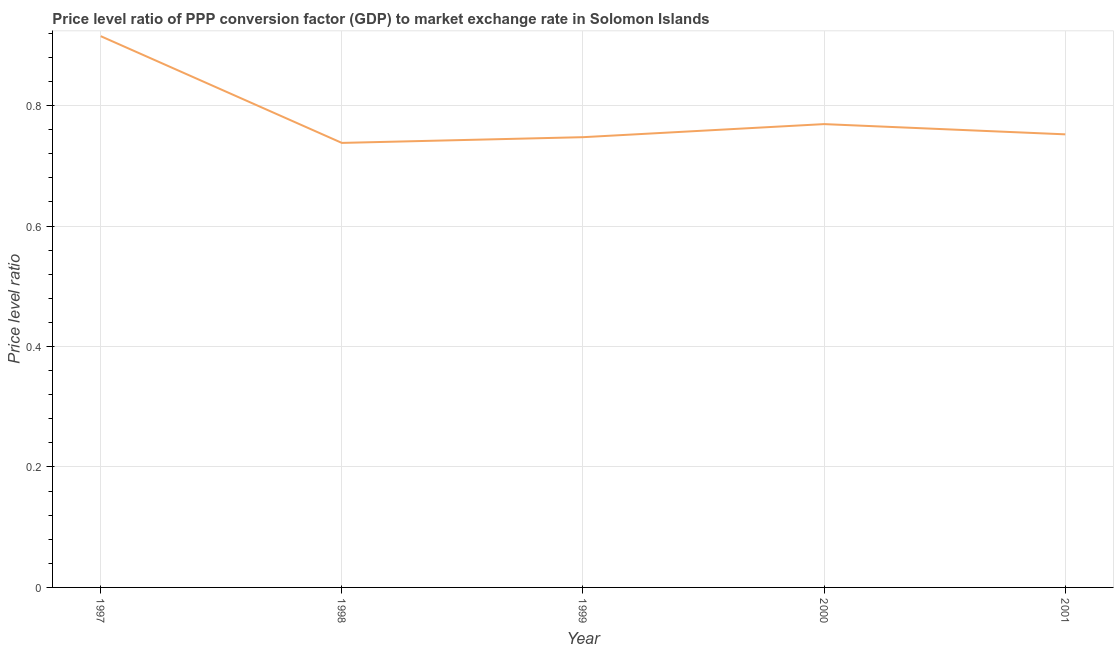What is the price level ratio in 2001?
Your response must be concise. 0.75. Across all years, what is the maximum price level ratio?
Offer a very short reply. 0.92. Across all years, what is the minimum price level ratio?
Offer a terse response. 0.74. In which year was the price level ratio minimum?
Your answer should be very brief. 1998. What is the sum of the price level ratio?
Your response must be concise. 3.92. What is the difference between the price level ratio in 1997 and 1999?
Offer a very short reply. 0.17. What is the average price level ratio per year?
Offer a very short reply. 0.78. What is the median price level ratio?
Ensure brevity in your answer.  0.75. What is the ratio of the price level ratio in 1997 to that in 2001?
Ensure brevity in your answer.  1.22. Is the price level ratio in 2000 less than that in 2001?
Give a very brief answer. No. What is the difference between the highest and the second highest price level ratio?
Ensure brevity in your answer.  0.15. What is the difference between the highest and the lowest price level ratio?
Offer a terse response. 0.18. Does the price level ratio monotonically increase over the years?
Make the answer very short. No. How many years are there in the graph?
Provide a succinct answer. 5. What is the difference between two consecutive major ticks on the Y-axis?
Provide a succinct answer. 0.2. What is the title of the graph?
Offer a very short reply. Price level ratio of PPP conversion factor (GDP) to market exchange rate in Solomon Islands. What is the label or title of the Y-axis?
Give a very brief answer. Price level ratio. What is the Price level ratio of 1997?
Provide a short and direct response. 0.92. What is the Price level ratio of 1998?
Offer a very short reply. 0.74. What is the Price level ratio of 1999?
Make the answer very short. 0.75. What is the Price level ratio in 2000?
Offer a very short reply. 0.77. What is the Price level ratio of 2001?
Give a very brief answer. 0.75. What is the difference between the Price level ratio in 1997 and 1998?
Offer a terse response. 0.18. What is the difference between the Price level ratio in 1997 and 1999?
Keep it short and to the point. 0.17. What is the difference between the Price level ratio in 1997 and 2000?
Provide a short and direct response. 0.15. What is the difference between the Price level ratio in 1997 and 2001?
Keep it short and to the point. 0.16. What is the difference between the Price level ratio in 1998 and 1999?
Your answer should be very brief. -0.01. What is the difference between the Price level ratio in 1998 and 2000?
Give a very brief answer. -0.03. What is the difference between the Price level ratio in 1998 and 2001?
Offer a very short reply. -0.01. What is the difference between the Price level ratio in 1999 and 2000?
Give a very brief answer. -0.02. What is the difference between the Price level ratio in 1999 and 2001?
Offer a terse response. -0. What is the difference between the Price level ratio in 2000 and 2001?
Ensure brevity in your answer.  0.02. What is the ratio of the Price level ratio in 1997 to that in 1998?
Make the answer very short. 1.24. What is the ratio of the Price level ratio in 1997 to that in 1999?
Offer a terse response. 1.22. What is the ratio of the Price level ratio in 1997 to that in 2000?
Your answer should be very brief. 1.19. What is the ratio of the Price level ratio in 1997 to that in 2001?
Your answer should be compact. 1.22. 